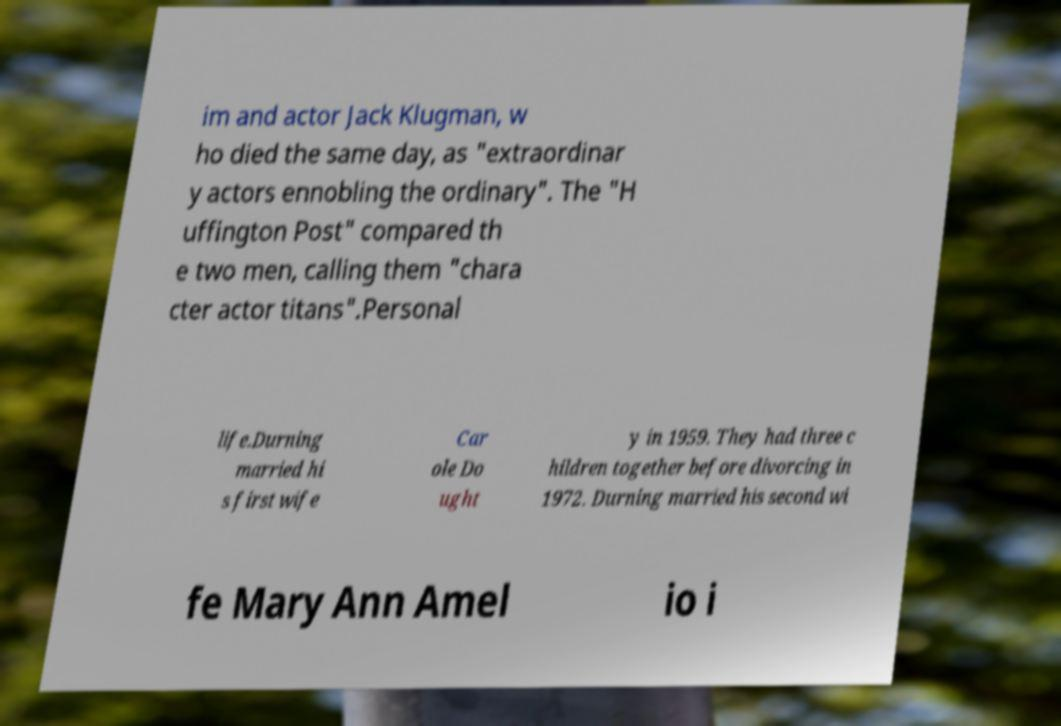There's text embedded in this image that I need extracted. Can you transcribe it verbatim? im and actor Jack Klugman, w ho died the same day, as "extraordinar y actors ennobling the ordinary". The "H uffington Post" compared th e two men, calling them "chara cter actor titans".Personal life.Durning married hi s first wife Car ole Do ught y in 1959. They had three c hildren together before divorcing in 1972. Durning married his second wi fe Mary Ann Amel io i 